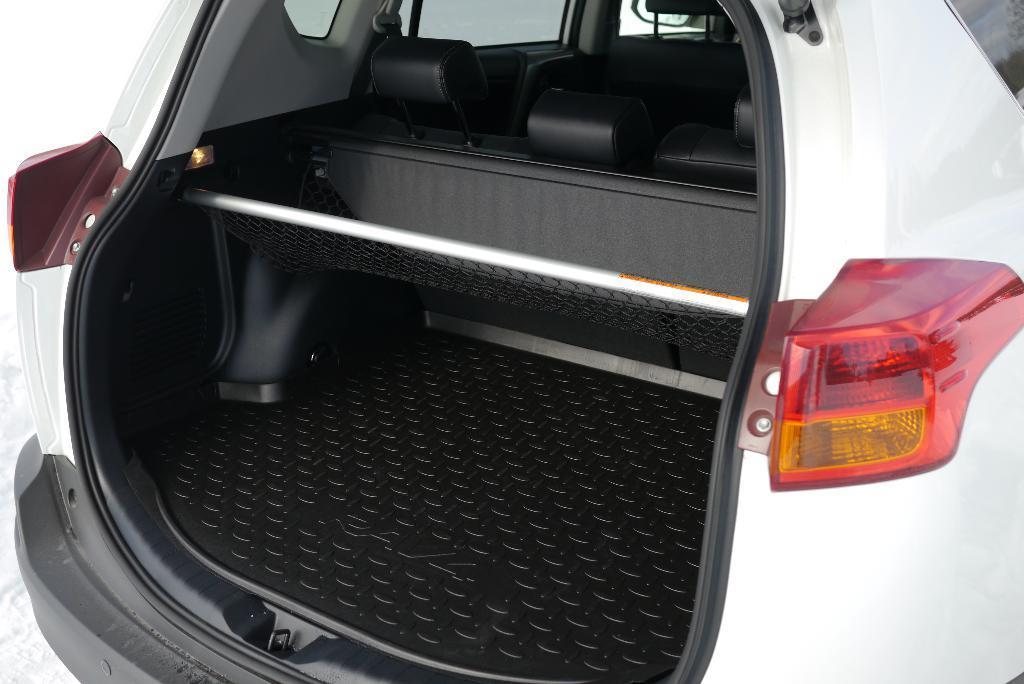How would you summarize this image in a sentence or two? In this picture we can see a car trunk, this car is of white color, on the right side we can see an indicator light and a danger light. 